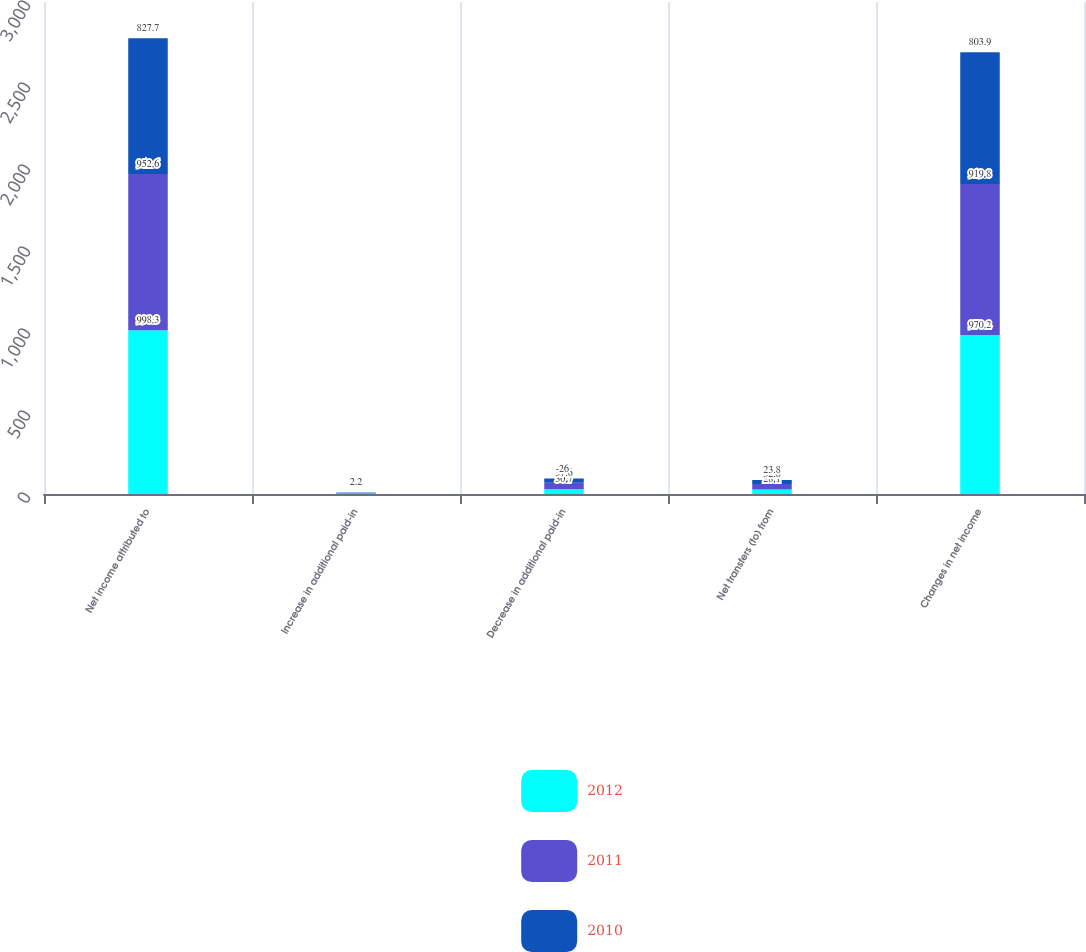Convert chart to OTSL. <chart><loc_0><loc_0><loc_500><loc_500><stacked_bar_chart><ecel><fcel>Net income attributed to<fcel>Increase in additional paid-in<fcel>Decrease in additional paid-in<fcel>Net transfers (to) from<fcel>Changes in net income<nl><fcel>2012<fcel>998.3<fcel>2.6<fcel>30.7<fcel>28.1<fcel>970.2<nl><fcel>2011<fcel>952.6<fcel>4.8<fcel>37.6<fcel>32.8<fcel>919.8<nl><fcel>2010<fcel>827.7<fcel>2.2<fcel>26<fcel>23.8<fcel>803.9<nl></chart> 